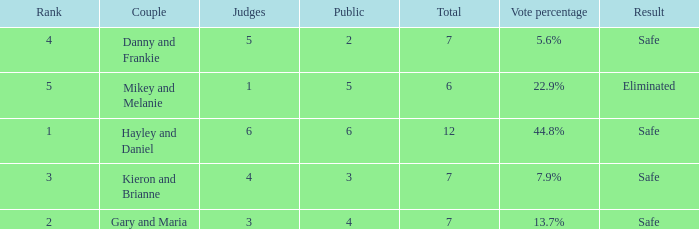What is the number of public that was there when the vote percentage was 22.9%? 1.0. 